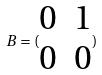<formula> <loc_0><loc_0><loc_500><loc_500>B = ( \begin{matrix} 0 & 1 \\ 0 & 0 \end{matrix} )</formula> 